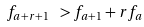Convert formula to latex. <formula><loc_0><loc_0><loc_500><loc_500>f _ { a + r + 1 } \ > f _ { a + 1 } + r f _ { a }</formula> 